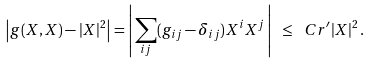<formula> <loc_0><loc_0><loc_500><loc_500>\left | g ( X , X ) - | X | ^ { 2 } \right | = \left | \, \sum _ { i j } ( g _ { i j } - \delta _ { i j } ) X ^ { i } X ^ { j } \, \right | \ \leq \ C r ^ { \prime } | X | ^ { 2 } \, .</formula> 